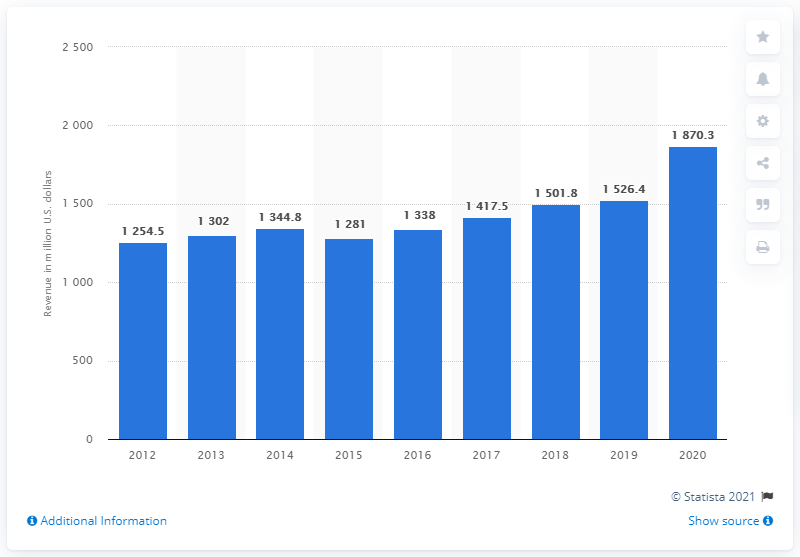Point out several critical features in this image. In 2020, the net sales of Qiagen in the United States were $1870.3 million. 